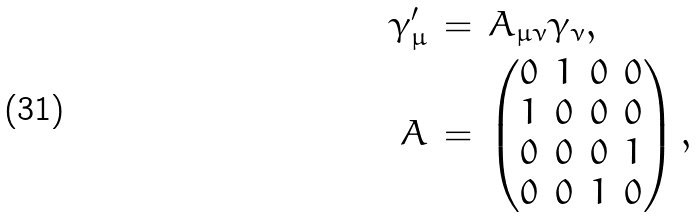<formula> <loc_0><loc_0><loc_500><loc_500>\gamma ^ { \prime } _ { \mu } \, & = \, A _ { \mu \nu } \gamma _ { \nu } , \\ A \, & = \, \left ( \begin{matrix} 0 & 1 & 0 & 0 \\ 1 & 0 & 0 & 0 \\ 0 & 0 & 0 & 1 \\ 0 & 0 & 1 & 0 \end{matrix} \right ) ,</formula> 